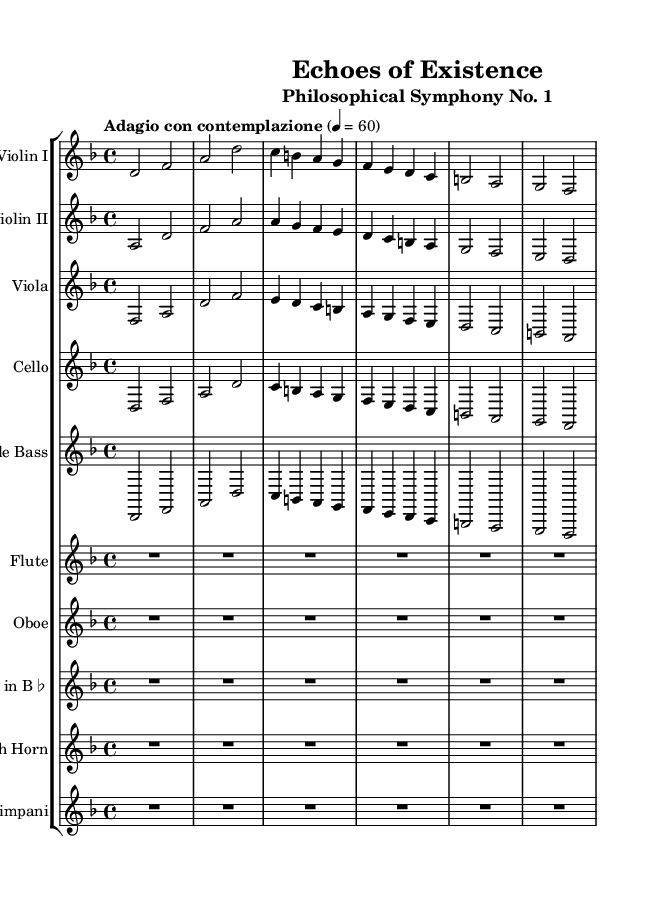What is the key signature of this symphony? The key signature can be determined by inspecting the opening of the piece where the key is indicated. Here, it specifies D minor, which has one flat (B flat).
Answer: D minor What is the time signature of the piece? The time signature is located at the beginning of the score next to the key signature. It shows a '4/4', indicating the piece is written in common time.
Answer: 4/4 What is the tempo marking for this piece? The tempo marking is positioned at the start of the composition, stating "Adagio con contemplazione," which indicates a slow and contemplative pace.
Answer: Adagio con contemplazione How many bars are there in the violin I part? By counting each measure in the violin I part from the start to the end of the excerpt, there are a total of six measures present.
Answer: Six Which instruments are featured in this symphony? By scanning the score's staff group, it lists the following instruments: Violin I, Violin II, Viola, Cello, Double Bass, Flute, Oboe, Clarinet, French Horn, and Timpani.
Answer: Ten instruments What melodic range does the flute occupy in this piece? The flute part shows a rest for a duration (R1*6) at the beginning, indicating it doesn't play in the provided excerpt, suggesting it may fill in dynamically with the strings later.
Answer: N/A 